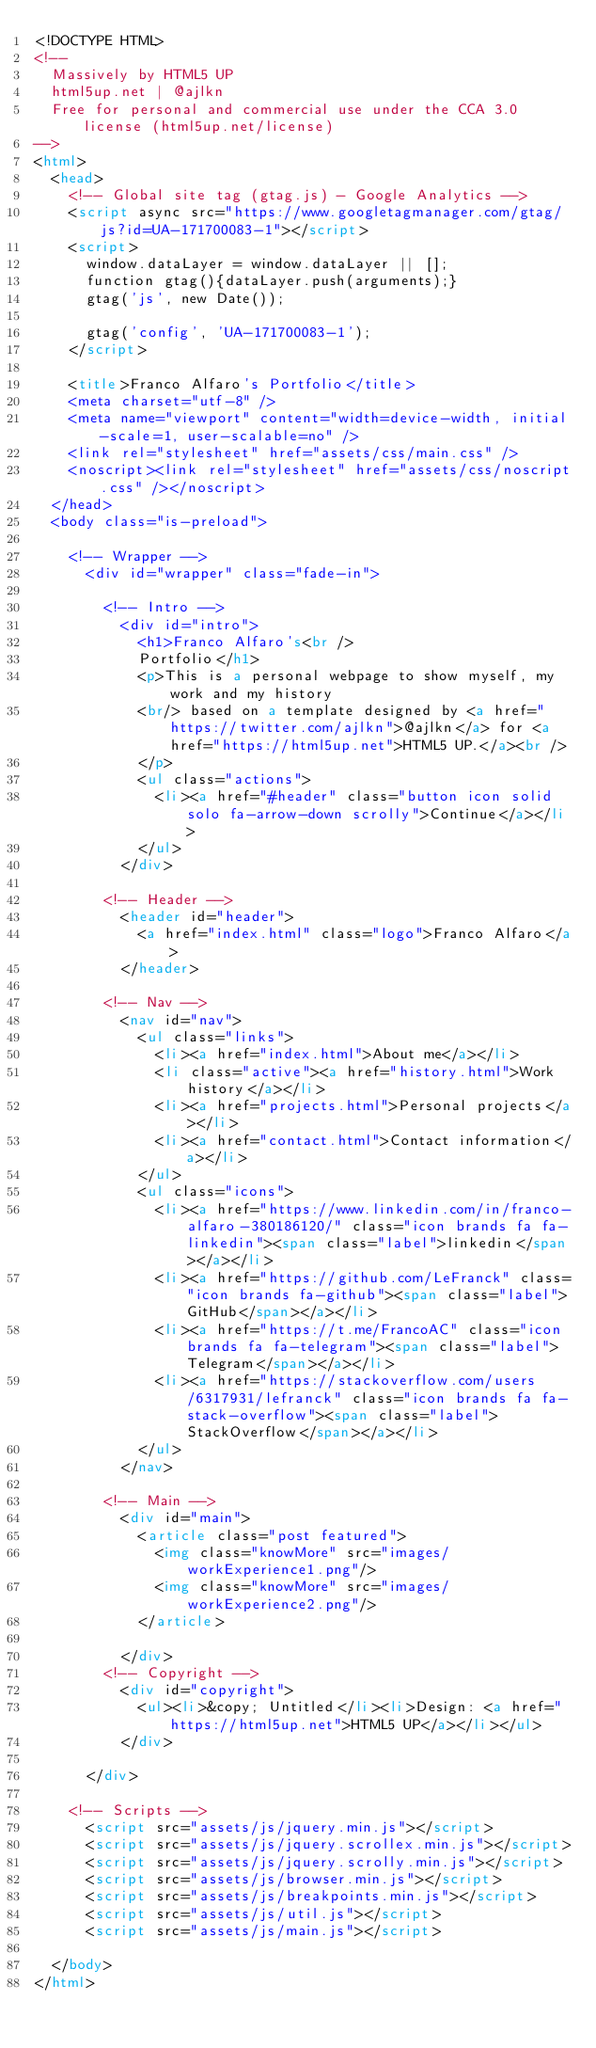<code> <loc_0><loc_0><loc_500><loc_500><_HTML_><!DOCTYPE HTML>
<!--
	Massively by HTML5 UP
	html5up.net | @ajlkn
	Free for personal and commercial use under the CCA 3.0 license (html5up.net/license)
-->
<html>
	<head>
		<!-- Global site tag (gtag.js) - Google Analytics -->
		<script async src="https://www.googletagmanager.com/gtag/js?id=UA-171700083-1"></script>
		<script>
		  window.dataLayer = window.dataLayer || [];
		  function gtag(){dataLayer.push(arguments);}
		  gtag('js', new Date());

		  gtag('config', 'UA-171700083-1');
		</script>

		<title>Franco Alfaro's Portfolio</title>
		<meta charset="utf-8" />
		<meta name="viewport" content="width=device-width, initial-scale=1, user-scalable=no" />
		<link rel="stylesheet" href="assets/css/main.css" />
		<noscript><link rel="stylesheet" href="assets/css/noscript.css" /></noscript>
	</head>
	<body class="is-preload">

		<!-- Wrapper -->
			<div id="wrapper" class="fade-in">

				<!-- Intro -->
					<div id="intro">
						<h1>Franco Alfaro's<br />
						Portfolio</h1>
						<p>This is a personal webpage to show myself, my work and my history  
						<br/> based on a template designed by <a href="https://twitter.com/ajlkn">@ajlkn</a> for <a href="https://html5up.net">HTML5 UP.</a><br />
						</p>
						<ul class="actions">
							<li><a href="#header" class="button icon solid solo fa-arrow-down scrolly">Continue</a></li>
						</ul>
					</div>

				<!-- Header -->
					<header id="header">
						<a href="index.html" class="logo">Franco Alfaro</a>
					</header>

				<!-- Nav -->
					<nav id="nav">
						<ul class="links">
							<li><a href="index.html">About me</a></li>
							<li class="active"><a href="history.html">Work history</a></li>
							<li><a href="projects.html">Personal projects</a></li>
							<li><a href="contact.html">Contact information</a></li>
						</ul>
						<ul class="icons">
							<li><a href="https://www.linkedin.com/in/franco-alfaro-380186120/" class="icon brands fa fa-linkedin"><span class="label">linkedin</span></a></li>
							<li><a href="https://github.com/LeFranck" class="icon brands fa-github"><span class="label">GitHub</span></a></li>
							<li><a href="https://t.me/FrancoAC" class="icon brands fa fa-telegram"><span class="label">Telegram</span></a></li>
							<li><a href="https://stackoverflow.com/users/6317931/lefranck" class="icon brands fa fa-stack-overflow"><span class="label">StackOverflow</span></a></li>
						</ul>
					</nav>

				<!-- Main -->
					<div id="main">
						<article class="post featured">
							<img class="knowMore" src="images/workExperience1.png"/>
							<img class="knowMore" src="images/workExperience2.png"/>
						</article>

					</div>
				<!-- Copyright -->
					<div id="copyright">
						<ul><li>&copy; Untitled</li><li>Design: <a href="https://html5up.net">HTML5 UP</a></li></ul>
					</div>

			</div>

		<!-- Scripts -->
			<script src="assets/js/jquery.min.js"></script>
			<script src="assets/js/jquery.scrollex.min.js"></script>
			<script src="assets/js/jquery.scrolly.min.js"></script>
			<script src="assets/js/browser.min.js"></script>
			<script src="assets/js/breakpoints.min.js"></script>
			<script src="assets/js/util.js"></script>
			<script src="assets/js/main.js"></script>

	</body>
</html></code> 